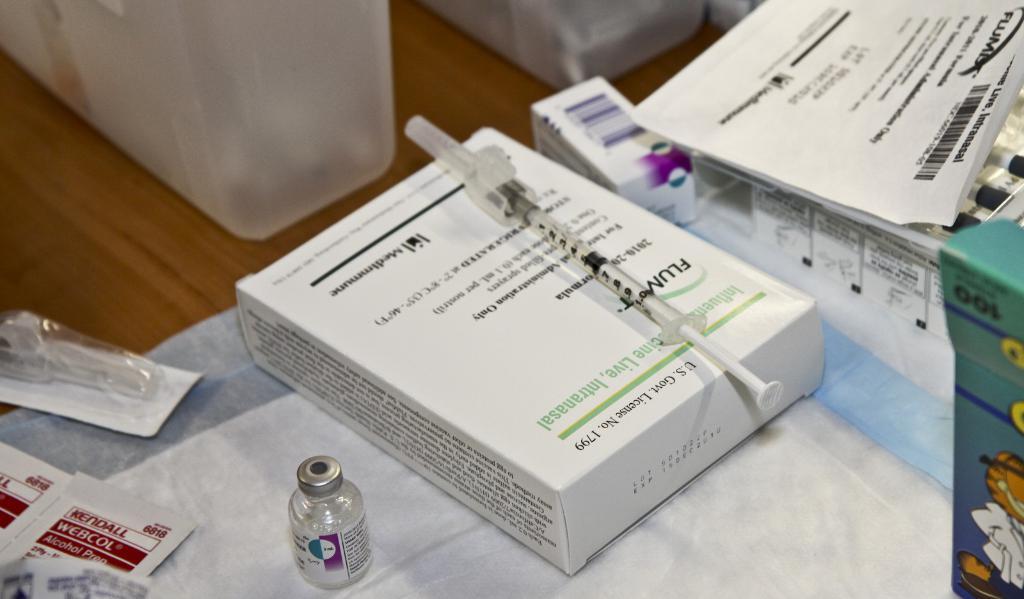Is this a flu shot?
Offer a very short reply. Yes. How many bandaids in the garfield box on the right?
Provide a short and direct response. 100. 